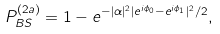<formula> <loc_0><loc_0><loc_500><loc_500>P _ { B S } ^ { ( 2 a ) } = 1 - e ^ { - | \alpha | ^ { 2 } | e ^ { i \phi _ { 0 } } - e ^ { i \phi _ { 1 } } | ^ { 2 } / 2 } ,</formula> 